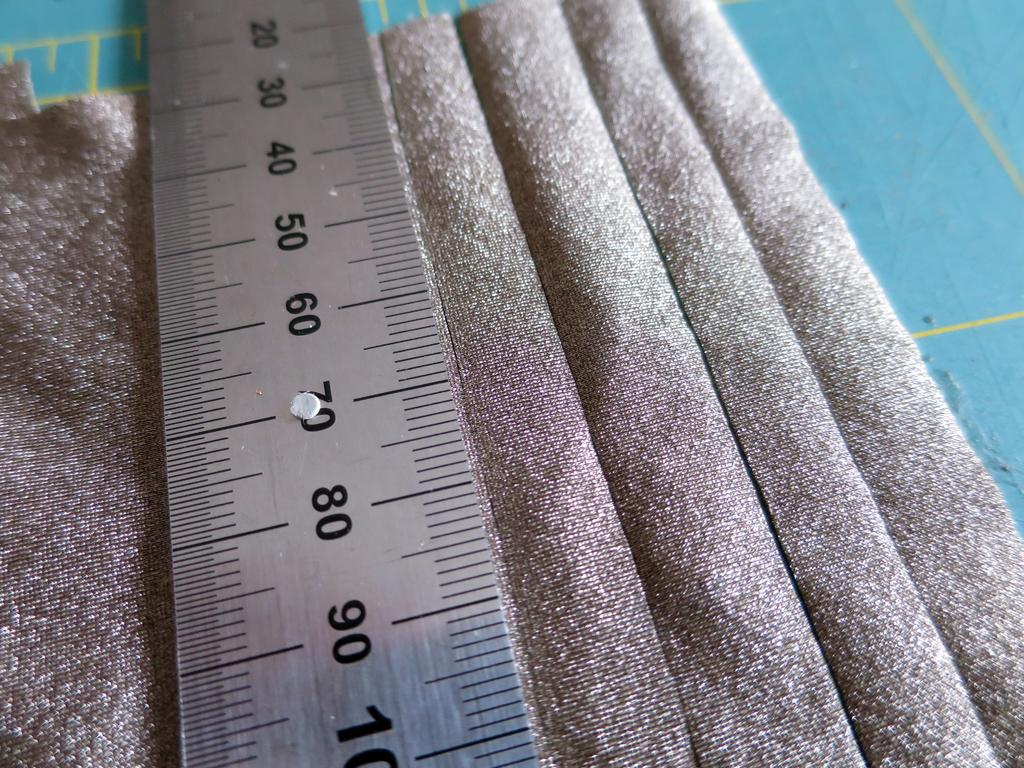<image>
Summarize the visual content of the image. A metal ruler with the numbers 20 through 100 displayed 